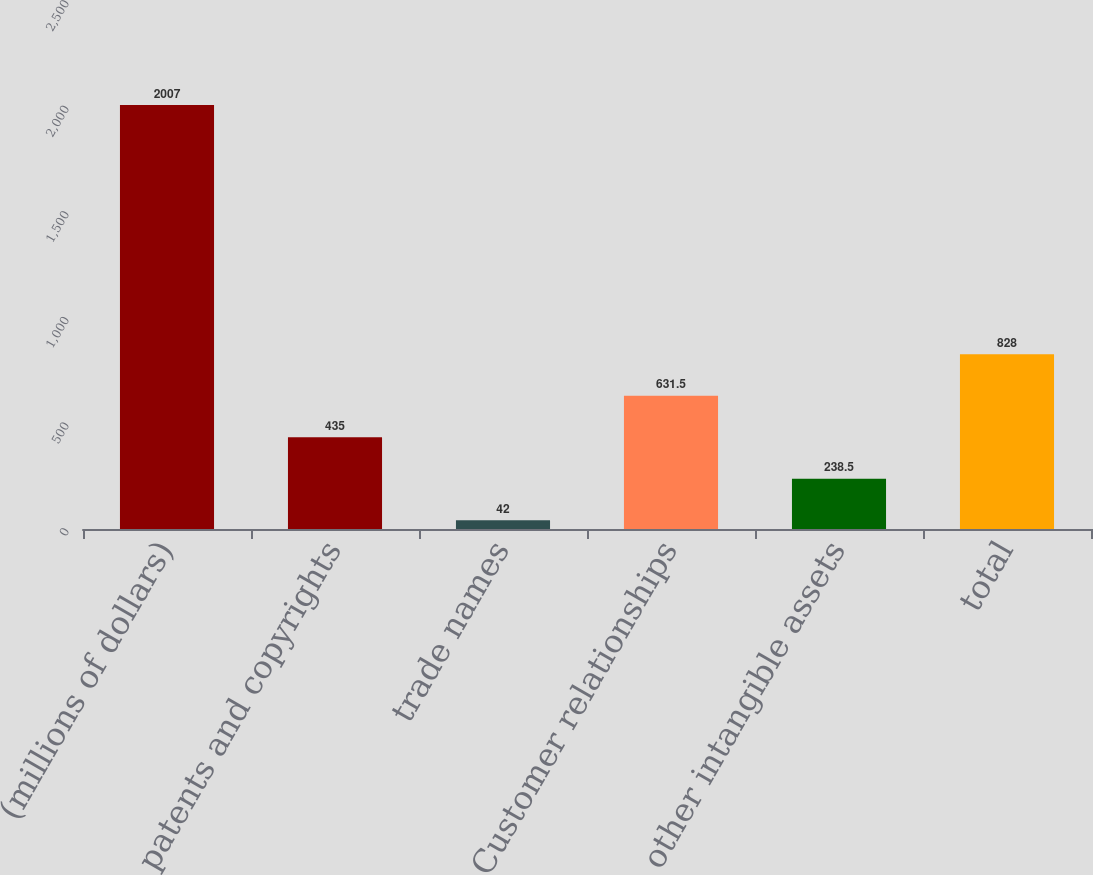Convert chart. <chart><loc_0><loc_0><loc_500><loc_500><bar_chart><fcel>(millions of dollars)<fcel>patents and copyrights<fcel>trade names<fcel>Customer relationships<fcel>other intangible assets<fcel>total<nl><fcel>2007<fcel>435<fcel>42<fcel>631.5<fcel>238.5<fcel>828<nl></chart> 